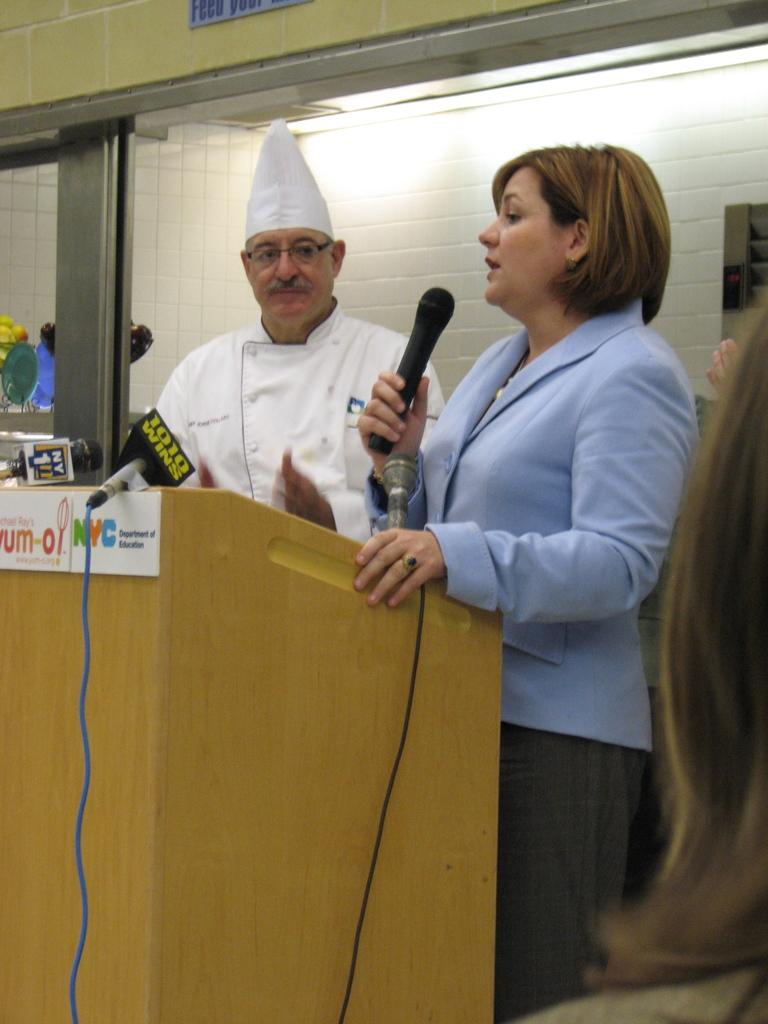Who are the people in the image? There is a man and a woman in the image. What are the man and woman doing in the image? Both the man and woman are standing at a podium. What is the woman doing specifically? The woman is speaking and holding a microphone in her hand. What type of bone is the woman holding in her hand? There is no bone present in the image; the woman is holding a microphone. What request is the minister making in the image? There is no minister present in the image, and no request is being made. 